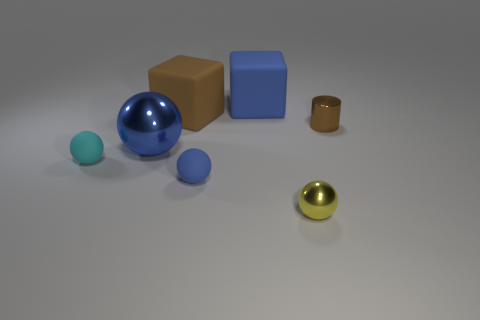Can you tell me what the largest object in the scene is? The largest object in the scene appears to be a brown rubber block situated in the center. 